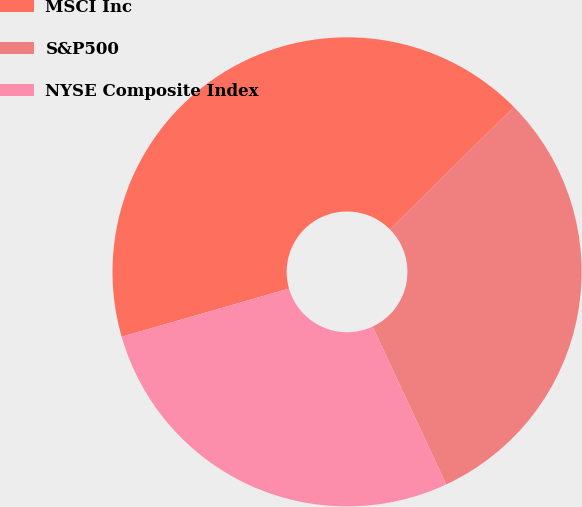Convert chart to OTSL. <chart><loc_0><loc_0><loc_500><loc_500><pie_chart><fcel>MSCI Inc<fcel>S&P500<fcel>NYSE Composite Index<nl><fcel>42.05%<fcel>30.46%<fcel>27.49%<nl></chart> 